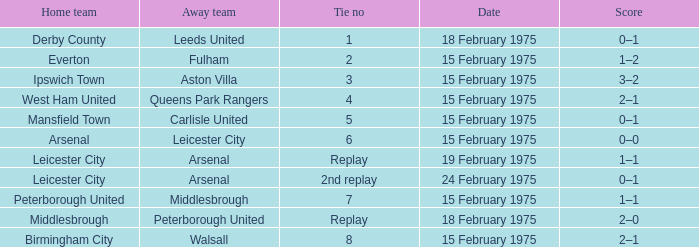What was the date when the away team was carlisle united? 15 February 1975. Would you mind parsing the complete table? {'header': ['Home team', 'Away team', 'Tie no', 'Date', 'Score'], 'rows': [['Derby County', 'Leeds United', '1', '18 February 1975', '0–1'], ['Everton', 'Fulham', '2', '15 February 1975', '1–2'], ['Ipswich Town', 'Aston Villa', '3', '15 February 1975', '3–2'], ['West Ham United', 'Queens Park Rangers', '4', '15 February 1975', '2–1'], ['Mansfield Town', 'Carlisle United', '5', '15 February 1975', '0–1'], ['Arsenal', 'Leicester City', '6', '15 February 1975', '0–0'], ['Leicester City', 'Arsenal', 'Replay', '19 February 1975', '1–1'], ['Leicester City', 'Arsenal', '2nd replay', '24 February 1975', '0–1'], ['Peterborough United', 'Middlesbrough', '7', '15 February 1975', '1–1'], ['Middlesbrough', 'Peterborough United', 'Replay', '18 February 1975', '2–0'], ['Birmingham City', 'Walsall', '8', '15 February 1975', '2–1']]} 